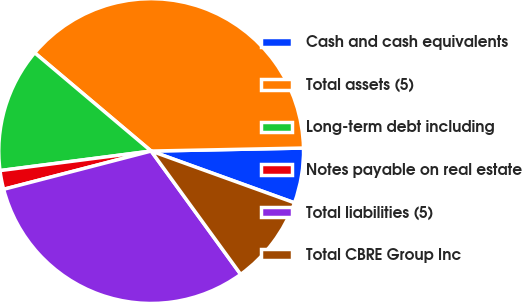Convert chart to OTSL. <chart><loc_0><loc_0><loc_500><loc_500><pie_chart><fcel>Cash and cash equivalents<fcel>Total assets (5)<fcel>Long-term debt including<fcel>Notes payable on real estate<fcel>Total liabilities (5)<fcel>Total CBRE Group Inc<nl><fcel>5.83%<fcel>38.53%<fcel>13.2%<fcel>1.99%<fcel>30.96%<fcel>9.49%<nl></chart> 